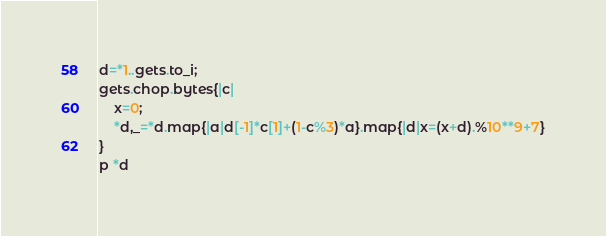<code> <loc_0><loc_0><loc_500><loc_500><_Ruby_>d=*1..gets.to_i;
gets.chop.bytes{|c|
	x=0;
	*d,_=*d.map{|a|d[-1]*c[1]+(1-c%3)*a}.map{|d|x=(x+d).%10**9+7}
}
p *d</code> 